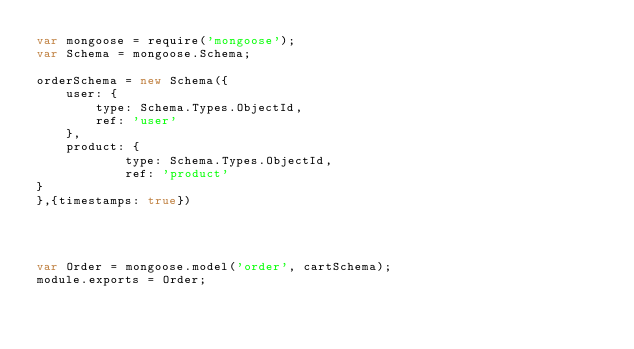<code> <loc_0><loc_0><loc_500><loc_500><_JavaScript_>var mongoose = require('mongoose');
var Schema = mongoose.Schema;

orderSchema = new Schema({
    user: {
        type: Schema.Types.ObjectId,
        ref: 'user'
    },
    product: {
            type: Schema.Types.ObjectId,
            ref: 'product'
}
},{timestamps: true})




var Order = mongoose.model('order', cartSchema);
module.exports = Order;</code> 